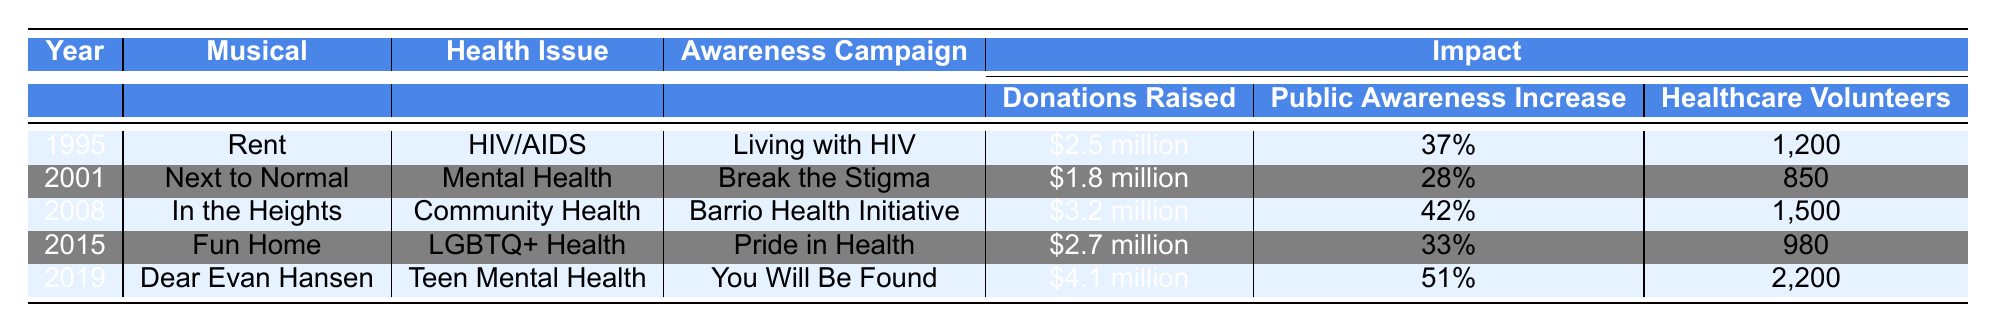What health issue did "Rent" focus on? "Rent" was released in 1995 and the table shows that it focused on the health issue of HIV/AIDS.
Answer: HIV/AIDS How much money was raised by the "In the Heights" awareness campaign? According to the table, "In the Heights" raised $3.2 million for the Barrio Health Initiative.
Answer: $3.2 million Which musical had the highest public awareness increase? Reviewing the table, "Dear Evan Hansen" had the highest public awareness increase at 51%.
Answer: 51% How many healthcare volunteers were recruited by "Fun Home"? The table indicates that "Fun Home" recruited 980 healthcare volunteers for its campaign.
Answer: 980 What is the total amount of donations raised by all the musicals listed? Summing the donations: $2.5M + $1.8M + $3.2M + $2.7M + $4.1M = $14.3 million total donations raised.
Answer: $14.3 million Which campaign had a lower percentage increase in public awareness, "Next to Normal" or "Fun Home"? "Next to Normal" had a 28% increase and "Fun Home" had a 33% increase; therefore, "Next to Normal" had the lower percentage increase.
Answer: "Next to Normal" What year did the musical "Dear Evan Hansen" raise the most donations compared to the others? The table shows that in 2019, "Dear Evan Hansen" raised $4.1 million, which is the highest compared to the other years listed.
Answer: 2019 Did "In the Heights" or "Rent" raise more donations for their campaigns? The table states that "In the Heights" raised $3.2 million and "Rent" raised $2.5 million, thus "In the Heights" raised more.
Answer: "In the Heights" Which health issue highlighted by musicals had the highest number of healthcare volunteers? "Dear Evan Hansen" had the highest number of healthcare volunteers with 2,200, according to the table.
Answer: Teen Mental Health Is the actual amount of donations raised by "Next to Normal" less than $2 million? "Next to Normal" raised $1.8 million; therefore, the statement is true.
Answer: Yes How many more healthcare volunteers were involved in the campaign for "Dear Evan Hansen" compared to "Fun Home"? "Dear Evan Hansen" had 2,200 volunteers while "Fun Home" had 980. The difference is 2,200 - 980 = 1,220 healthcare volunteers.
Answer: 1,220 